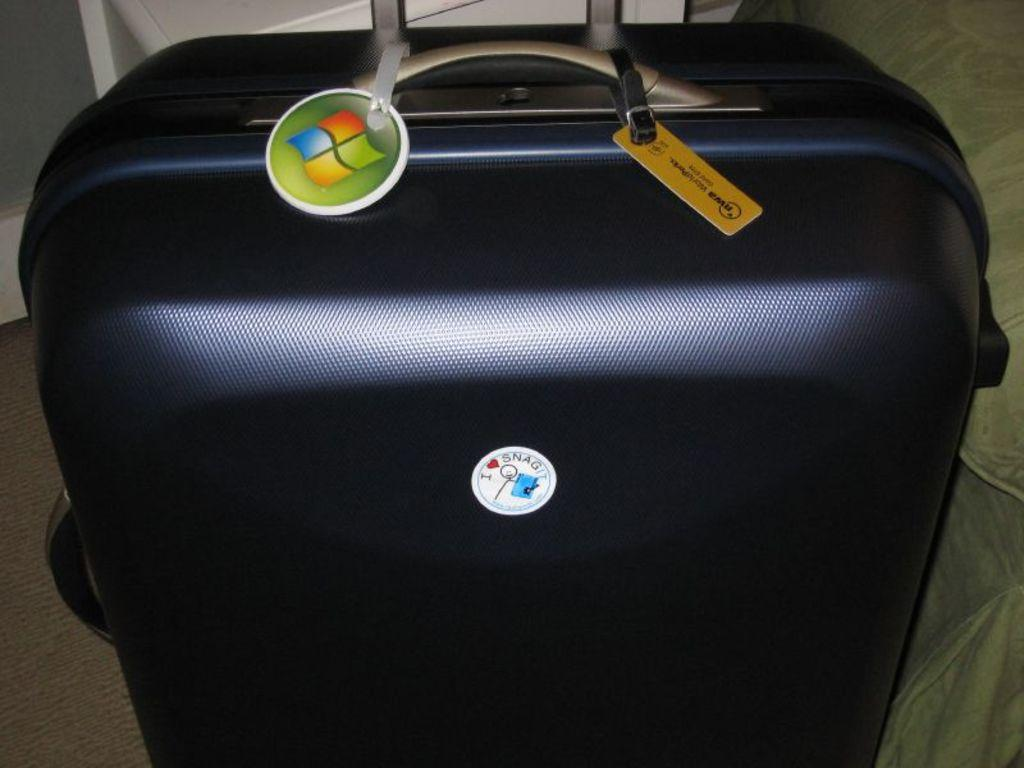What object can be seen in the image? There is a bag in the image. What is the color of the bag? The bag is black in color. How much rice is inside the bag in the image? There is no information about rice or its quantity in the image, as it only features a black bag. 